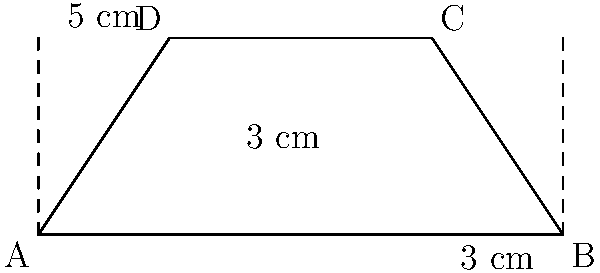A Swedish school is planning an exchange program and needs to calculate the area of a banner for the welcome ceremony. The banner has the shape of a trapezoid with parallel sides measuring 5 cm and 3 cm, and a height of 3 cm. Calculate the area of the trapezoid-shaped banner in square centimeters. To find the area of a trapezoid, we can use the formula:

$$A = \frac{1}{2}(a + b)h$$

Where:
$A$ = Area of the trapezoid
$a$ = Length of one parallel side
$b$ = Length of the other parallel side
$h$ = Height of the trapezoid

Given:
$a = 5$ cm
$b = 3$ cm
$h = 3$ cm

Let's substitute these values into the formula:

$$A = \frac{1}{2}(5 + 3) \times 3$$

$$A = \frac{1}{2}(8) \times 3$$

$$A = 4 \times 3$$

$$A = 12$$

Therefore, the area of the trapezoid-shaped banner is 12 square centimeters.
Answer: 12 cm² 